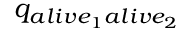<formula> <loc_0><loc_0><loc_500><loc_500>q _ { a l i v e _ { 1 } a l i v e _ { 2 } }</formula> 